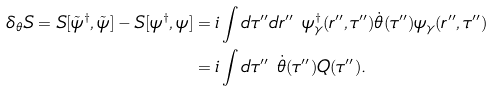<formula> <loc_0><loc_0><loc_500><loc_500>\delta _ { \theta } S = S [ \tilde { \psi } ^ { \dag } , \tilde { \psi } ] - S [ \psi ^ { \dag } , \psi ] & = i \int d \tau ^ { \prime \prime } d r ^ { \prime \prime } \ \psi _ { \gamma } ^ { \dag } ( r ^ { \prime \prime } , \tau ^ { \prime \prime } ) \dot { \theta } ( \tau ^ { \prime \prime } ) \psi _ { \gamma } ( r ^ { \prime \prime } , \tau ^ { \prime \prime } ) \\ & = i \int d \tau ^ { \prime \prime } \ \dot { \theta } ( \tau ^ { \prime \prime } ) Q ( \tau ^ { \prime \prime } ) .</formula> 